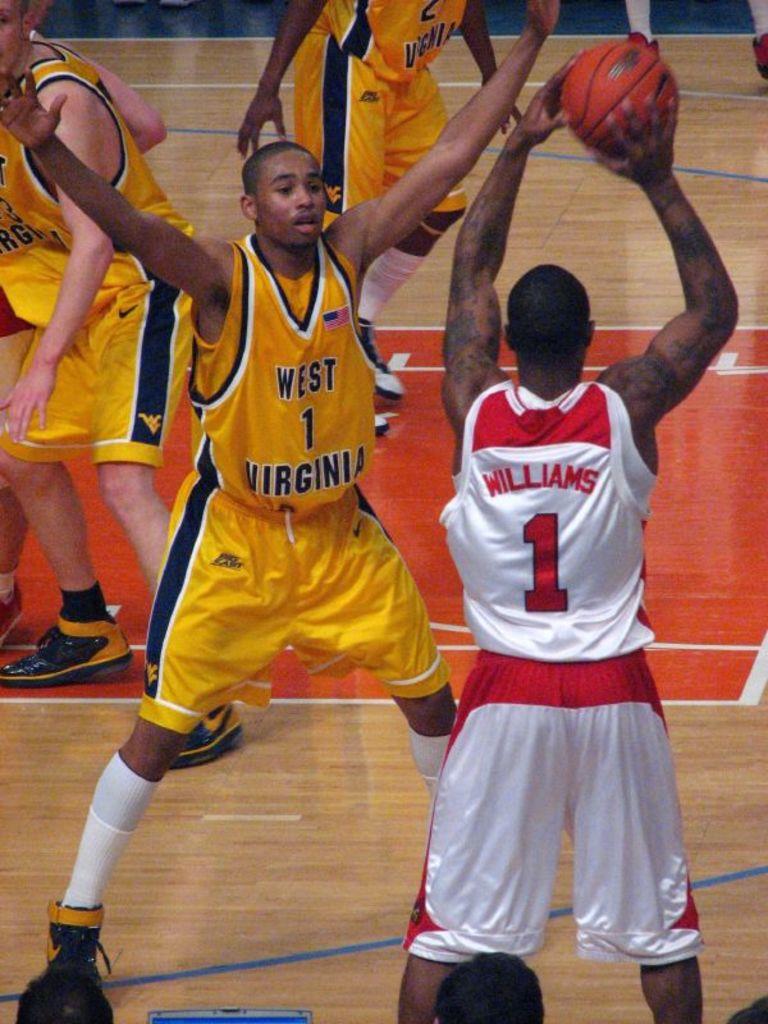What number is the player in white?
Give a very brief answer. 1. 